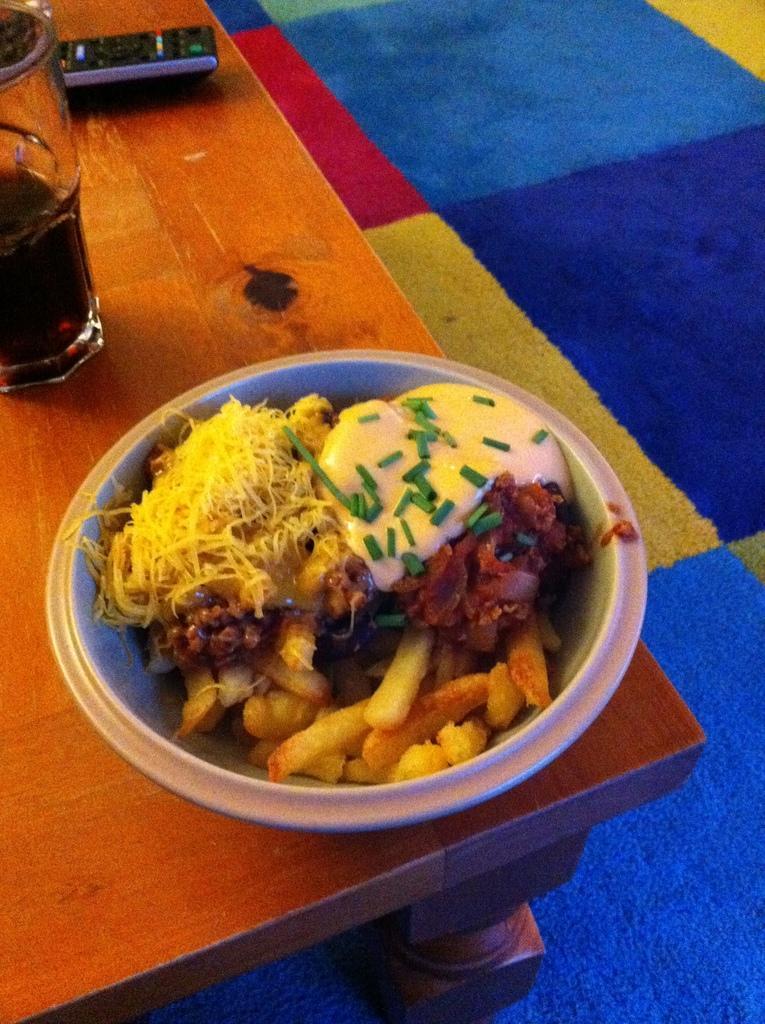Can you describe this image briefly? In this image we can see a table. On the table there are a serving bowl with food in it, beverage bottle and a remote. In the background we can see a carpet on the floor. 